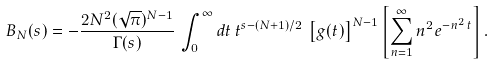<formula> <loc_0><loc_0><loc_500><loc_500>B _ { N } ( s ) = - \frac { 2 N ^ { 2 } ( \sqrt { \pi } ) ^ { N - 1 } } { \Gamma ( s ) } \, \int _ { 0 } ^ { \infty } d t \, t ^ { s - ( N + 1 ) / 2 } \, \left [ g ( t ) \right ] ^ { N - 1 } \left [ \sum _ { n = 1 } ^ { \infty } n ^ { 2 } e ^ { - n ^ { 2 } \, t } \right ] .</formula> 